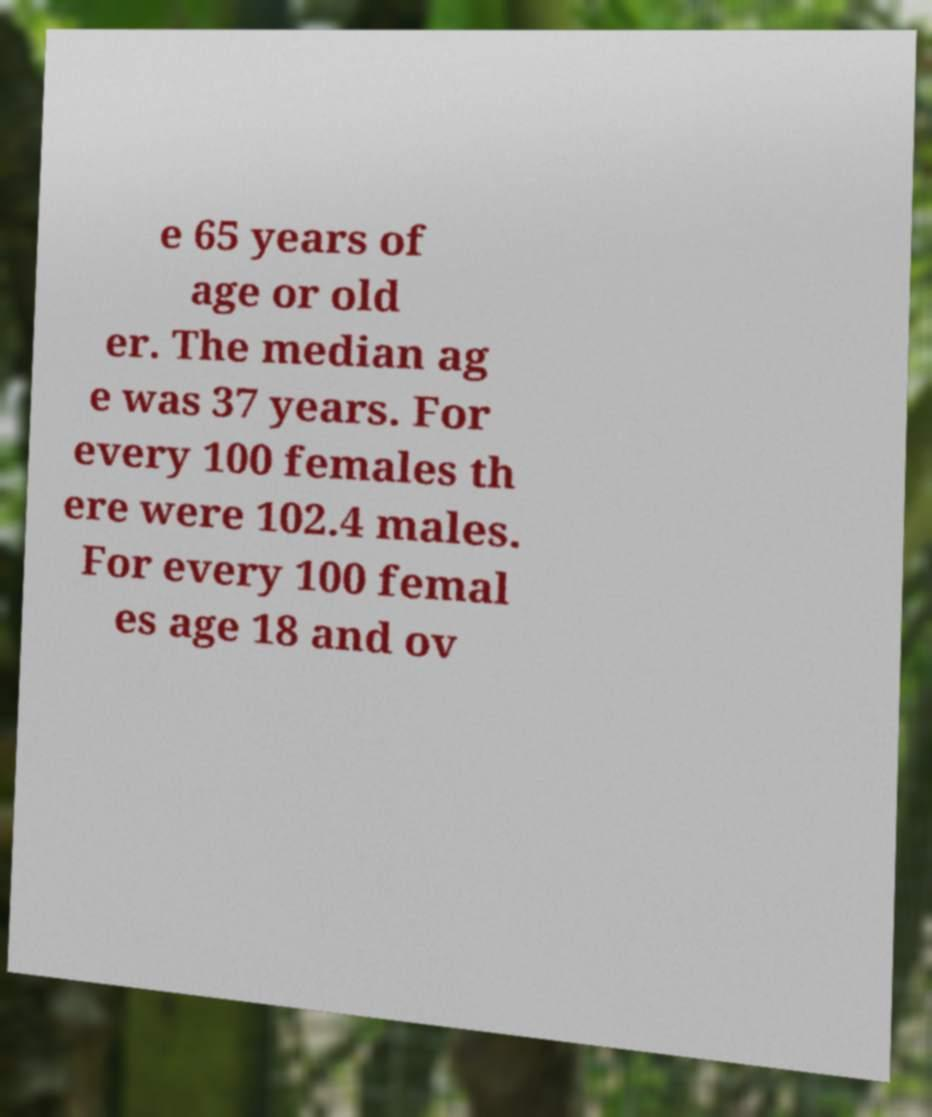Can you accurately transcribe the text from the provided image for me? e 65 years of age or old er. The median ag e was 37 years. For every 100 females th ere were 102.4 males. For every 100 femal es age 18 and ov 